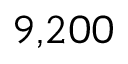<formula> <loc_0><loc_0><loc_500><loc_500>9 { , } 2 0 0</formula> 